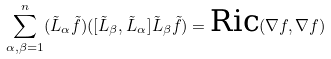Convert formula to latex. <formula><loc_0><loc_0><loc_500><loc_500>\sum _ { \alpha , \beta = 1 } ^ { n } ( \tilde { L } _ { \alpha } \tilde { f } ) ( [ \tilde { L } _ { \beta } , \tilde { L } _ { \alpha } ] \tilde { L } _ { \beta } \tilde { f } ) = \text {Ric} ( \nabla f , \nabla f )</formula> 